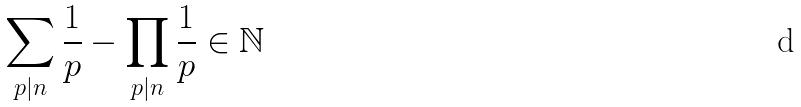Convert formula to latex. <formula><loc_0><loc_0><loc_500><loc_500>\sum _ { p | n } \frac { 1 } { p } - \prod _ { p | n } \frac { 1 } { p } \in \mathbb { N }</formula> 